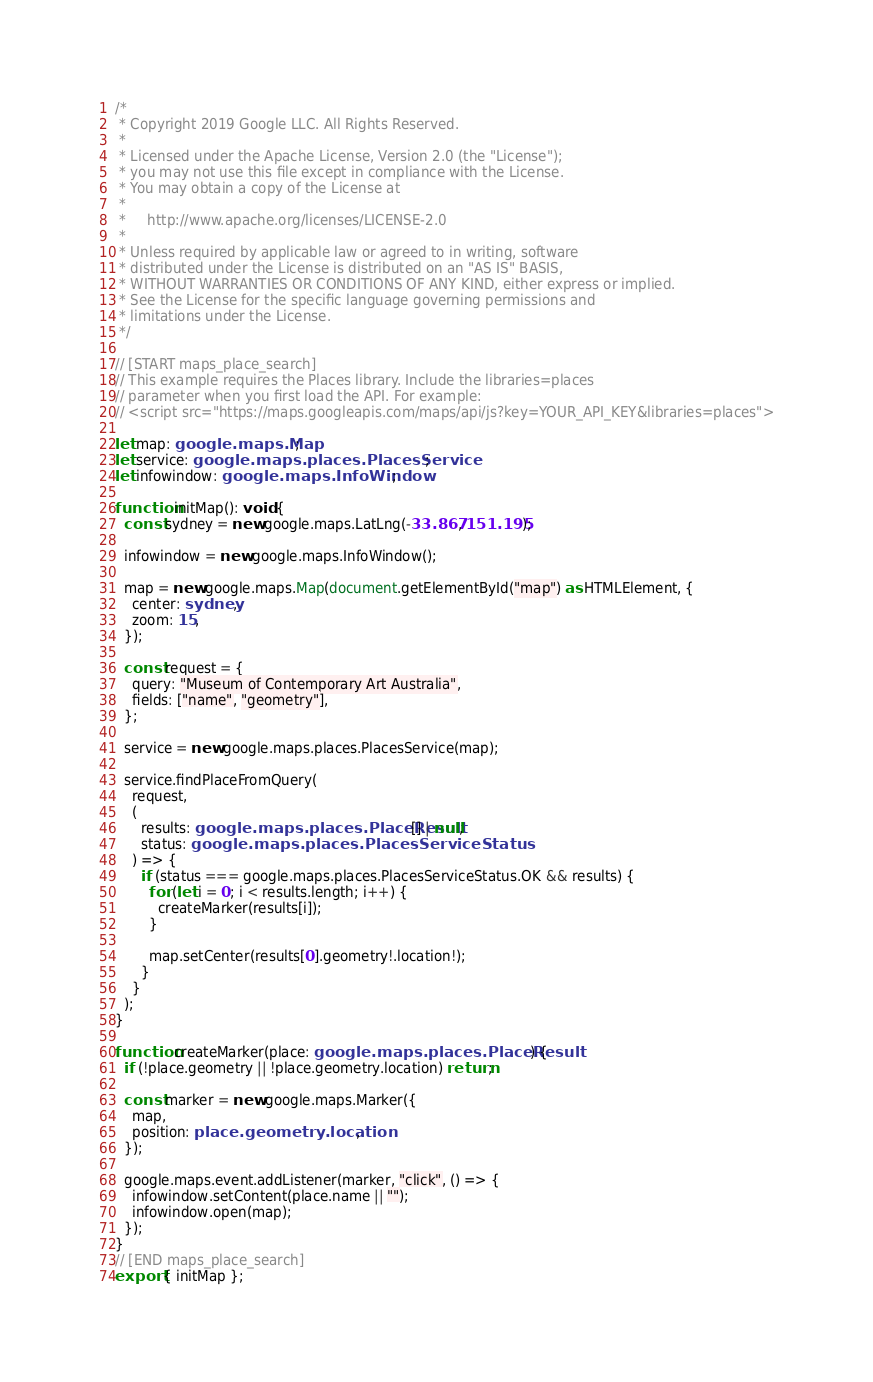Convert code to text. <code><loc_0><loc_0><loc_500><loc_500><_TypeScript_>/*
 * Copyright 2019 Google LLC. All Rights Reserved.
 *
 * Licensed under the Apache License, Version 2.0 (the "License");
 * you may not use this file except in compliance with the License.
 * You may obtain a copy of the License at
 *
 *     http://www.apache.org/licenses/LICENSE-2.0
 *
 * Unless required by applicable law or agreed to in writing, software
 * distributed under the License is distributed on an "AS IS" BASIS,
 * WITHOUT WARRANTIES OR CONDITIONS OF ANY KIND, either express or implied.
 * See the License for the specific language governing permissions and
 * limitations under the License.
 */

// [START maps_place_search]
// This example requires the Places library. Include the libraries=places
// parameter when you first load the API. For example:
// <script src="https://maps.googleapis.com/maps/api/js?key=YOUR_API_KEY&libraries=places">

let map: google.maps.Map;
let service: google.maps.places.PlacesService;
let infowindow: google.maps.InfoWindow;

function initMap(): void {
  const sydney = new google.maps.LatLng(-33.867, 151.195);

  infowindow = new google.maps.InfoWindow();

  map = new google.maps.Map(document.getElementById("map") as HTMLElement, {
    center: sydney,
    zoom: 15,
  });

  const request = {
    query: "Museum of Contemporary Art Australia",
    fields: ["name", "geometry"],
  };

  service = new google.maps.places.PlacesService(map);

  service.findPlaceFromQuery(
    request,
    (
      results: google.maps.places.PlaceResult[] | null,
      status: google.maps.places.PlacesServiceStatus
    ) => {
      if (status === google.maps.places.PlacesServiceStatus.OK && results) {
        for (let i = 0; i < results.length; i++) {
          createMarker(results[i]);
        }

        map.setCenter(results[0].geometry!.location!);
      }
    }
  );
}

function createMarker(place: google.maps.places.PlaceResult) {
  if (!place.geometry || !place.geometry.location) return;

  const marker = new google.maps.Marker({
    map,
    position: place.geometry.location,
  });

  google.maps.event.addListener(marker, "click", () => {
    infowindow.setContent(place.name || "");
    infowindow.open(map);
  });
}
// [END maps_place_search]
export { initMap };
</code> 